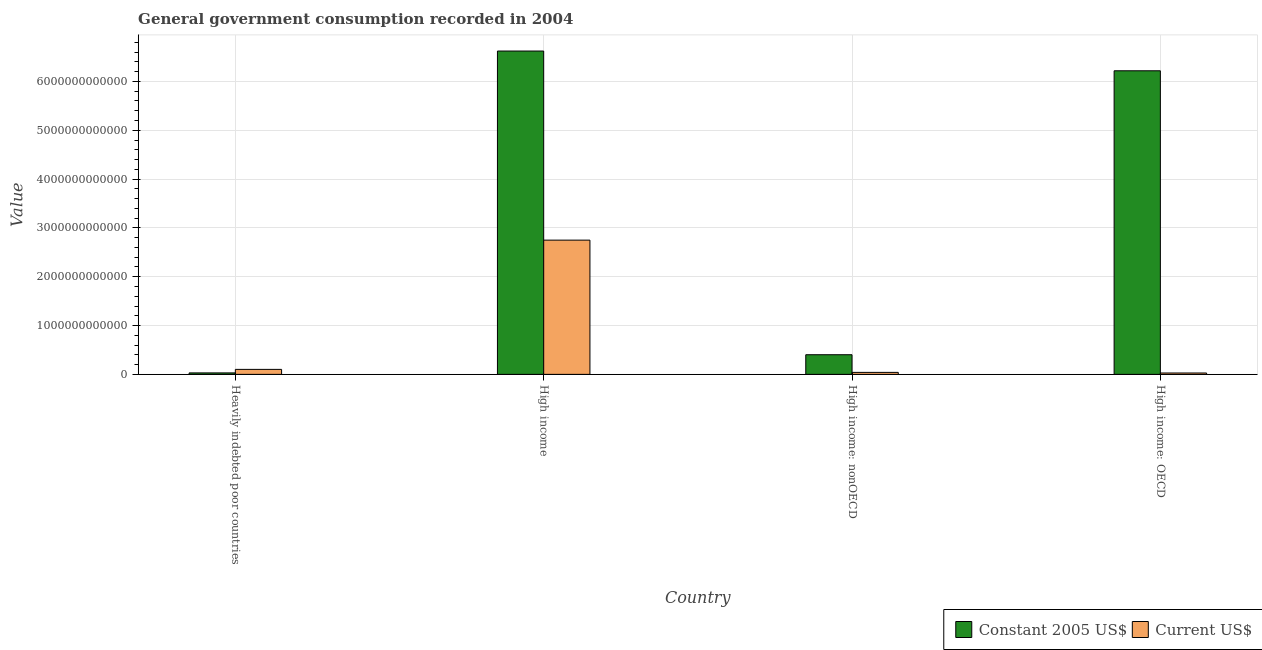How many different coloured bars are there?
Provide a succinct answer. 2. How many groups of bars are there?
Your answer should be very brief. 4. Are the number of bars on each tick of the X-axis equal?
Keep it short and to the point. Yes. What is the label of the 1st group of bars from the left?
Your answer should be very brief. Heavily indebted poor countries. In how many cases, is the number of bars for a given country not equal to the number of legend labels?
Your response must be concise. 0. What is the value consumed in constant 2005 us$ in High income?
Your answer should be compact. 6.62e+12. Across all countries, what is the maximum value consumed in constant 2005 us$?
Provide a short and direct response. 6.62e+12. Across all countries, what is the minimum value consumed in current us$?
Provide a succinct answer. 2.84e+1. In which country was the value consumed in constant 2005 us$ maximum?
Your response must be concise. High income. In which country was the value consumed in constant 2005 us$ minimum?
Provide a short and direct response. Heavily indebted poor countries. What is the total value consumed in constant 2005 us$ in the graph?
Offer a very short reply. 1.33e+13. What is the difference between the value consumed in constant 2005 us$ in Heavily indebted poor countries and that in High income: nonOECD?
Your answer should be very brief. -3.72e+11. What is the difference between the value consumed in current us$ in High income: OECD and the value consumed in constant 2005 us$ in High income?
Ensure brevity in your answer.  -6.59e+12. What is the average value consumed in current us$ per country?
Your answer should be compact. 7.30e+11. What is the difference between the value consumed in constant 2005 us$ and value consumed in current us$ in Heavily indebted poor countries?
Make the answer very short. -7.21e+1. In how many countries, is the value consumed in current us$ greater than 6600000000000 ?
Offer a terse response. 0. What is the ratio of the value consumed in constant 2005 us$ in High income to that in High income: OECD?
Make the answer very short. 1.07. Is the difference between the value consumed in current us$ in High income and High income: OECD greater than the difference between the value consumed in constant 2005 us$ in High income and High income: OECD?
Give a very brief answer. Yes. What is the difference between the highest and the second highest value consumed in constant 2005 us$?
Provide a short and direct response. 4.05e+11. What is the difference between the highest and the lowest value consumed in current us$?
Make the answer very short. 2.72e+12. Is the sum of the value consumed in current us$ in High income and High income: nonOECD greater than the maximum value consumed in constant 2005 us$ across all countries?
Make the answer very short. No. What does the 1st bar from the left in Heavily indebted poor countries represents?
Make the answer very short. Constant 2005 US$. What does the 1st bar from the right in Heavily indebted poor countries represents?
Your response must be concise. Current US$. How many bars are there?
Make the answer very short. 8. How many countries are there in the graph?
Offer a very short reply. 4. What is the difference between two consecutive major ticks on the Y-axis?
Your answer should be compact. 1.00e+12. Does the graph contain any zero values?
Provide a succinct answer. No. Where does the legend appear in the graph?
Offer a terse response. Bottom right. How are the legend labels stacked?
Your answer should be compact. Horizontal. What is the title of the graph?
Ensure brevity in your answer.  General government consumption recorded in 2004. What is the label or title of the Y-axis?
Offer a very short reply. Value. What is the Value of Constant 2005 US$ in Heavily indebted poor countries?
Your answer should be compact. 3.01e+1. What is the Value in Current US$ in Heavily indebted poor countries?
Your answer should be very brief. 1.02e+11. What is the Value in Constant 2005 US$ in High income?
Ensure brevity in your answer.  6.62e+12. What is the Value in Current US$ in High income?
Keep it short and to the point. 2.75e+12. What is the Value of Constant 2005 US$ in High income: nonOECD?
Give a very brief answer. 4.02e+11. What is the Value in Current US$ in High income: nonOECD?
Offer a very short reply. 4.08e+1. What is the Value of Constant 2005 US$ in High income: OECD?
Make the answer very short. 6.22e+12. What is the Value of Current US$ in High income: OECD?
Offer a very short reply. 2.84e+1. Across all countries, what is the maximum Value of Constant 2005 US$?
Keep it short and to the point. 6.62e+12. Across all countries, what is the maximum Value in Current US$?
Provide a short and direct response. 2.75e+12. Across all countries, what is the minimum Value in Constant 2005 US$?
Make the answer very short. 3.01e+1. Across all countries, what is the minimum Value of Current US$?
Keep it short and to the point. 2.84e+1. What is the total Value of Constant 2005 US$ in the graph?
Keep it short and to the point. 1.33e+13. What is the total Value of Current US$ in the graph?
Keep it short and to the point. 2.92e+12. What is the difference between the Value of Constant 2005 US$ in Heavily indebted poor countries and that in High income?
Offer a very short reply. -6.59e+12. What is the difference between the Value in Current US$ in Heavily indebted poor countries and that in High income?
Your response must be concise. -2.65e+12. What is the difference between the Value in Constant 2005 US$ in Heavily indebted poor countries and that in High income: nonOECD?
Keep it short and to the point. -3.72e+11. What is the difference between the Value of Current US$ in Heavily indebted poor countries and that in High income: nonOECD?
Your answer should be very brief. 6.14e+1. What is the difference between the Value of Constant 2005 US$ in Heavily indebted poor countries and that in High income: OECD?
Ensure brevity in your answer.  -6.19e+12. What is the difference between the Value of Current US$ in Heavily indebted poor countries and that in High income: OECD?
Provide a succinct answer. 7.38e+1. What is the difference between the Value in Constant 2005 US$ in High income and that in High income: nonOECD?
Offer a terse response. 6.22e+12. What is the difference between the Value of Current US$ in High income and that in High income: nonOECD?
Your answer should be very brief. 2.71e+12. What is the difference between the Value in Constant 2005 US$ in High income and that in High income: OECD?
Offer a very short reply. 4.05e+11. What is the difference between the Value of Current US$ in High income and that in High income: OECD?
Your answer should be compact. 2.72e+12. What is the difference between the Value in Constant 2005 US$ in High income: nonOECD and that in High income: OECD?
Ensure brevity in your answer.  -5.82e+12. What is the difference between the Value of Current US$ in High income: nonOECD and that in High income: OECD?
Provide a succinct answer. 1.23e+1. What is the difference between the Value of Constant 2005 US$ in Heavily indebted poor countries and the Value of Current US$ in High income?
Provide a succinct answer. -2.72e+12. What is the difference between the Value of Constant 2005 US$ in Heavily indebted poor countries and the Value of Current US$ in High income: nonOECD?
Offer a very short reply. -1.06e+1. What is the difference between the Value in Constant 2005 US$ in Heavily indebted poor countries and the Value in Current US$ in High income: OECD?
Keep it short and to the point. 1.72e+09. What is the difference between the Value of Constant 2005 US$ in High income and the Value of Current US$ in High income: nonOECD?
Offer a terse response. 6.58e+12. What is the difference between the Value of Constant 2005 US$ in High income and the Value of Current US$ in High income: OECD?
Offer a very short reply. 6.59e+12. What is the difference between the Value in Constant 2005 US$ in High income: nonOECD and the Value in Current US$ in High income: OECD?
Keep it short and to the point. 3.74e+11. What is the average Value in Constant 2005 US$ per country?
Ensure brevity in your answer.  3.32e+12. What is the average Value in Current US$ per country?
Keep it short and to the point. 7.30e+11. What is the difference between the Value in Constant 2005 US$ and Value in Current US$ in Heavily indebted poor countries?
Ensure brevity in your answer.  -7.21e+1. What is the difference between the Value in Constant 2005 US$ and Value in Current US$ in High income?
Offer a terse response. 3.87e+12. What is the difference between the Value of Constant 2005 US$ and Value of Current US$ in High income: nonOECD?
Provide a short and direct response. 3.62e+11. What is the difference between the Value of Constant 2005 US$ and Value of Current US$ in High income: OECD?
Offer a very short reply. 6.19e+12. What is the ratio of the Value in Constant 2005 US$ in Heavily indebted poor countries to that in High income?
Offer a terse response. 0. What is the ratio of the Value in Current US$ in Heavily indebted poor countries to that in High income?
Your response must be concise. 0.04. What is the ratio of the Value in Constant 2005 US$ in Heavily indebted poor countries to that in High income: nonOECD?
Provide a succinct answer. 0.07. What is the ratio of the Value in Current US$ in Heavily indebted poor countries to that in High income: nonOECD?
Your answer should be very brief. 2.51. What is the ratio of the Value of Constant 2005 US$ in Heavily indebted poor countries to that in High income: OECD?
Your answer should be compact. 0. What is the ratio of the Value in Current US$ in Heavily indebted poor countries to that in High income: OECD?
Your response must be concise. 3.6. What is the ratio of the Value in Constant 2005 US$ in High income to that in High income: nonOECD?
Offer a terse response. 16.46. What is the ratio of the Value of Current US$ in High income to that in High income: nonOECD?
Give a very brief answer. 67.47. What is the ratio of the Value of Constant 2005 US$ in High income to that in High income: OECD?
Your answer should be compact. 1.07. What is the ratio of the Value of Current US$ in High income to that in High income: OECD?
Provide a succinct answer. 96.8. What is the ratio of the Value in Constant 2005 US$ in High income: nonOECD to that in High income: OECD?
Your answer should be very brief. 0.06. What is the ratio of the Value of Current US$ in High income: nonOECD to that in High income: OECD?
Offer a terse response. 1.43. What is the difference between the highest and the second highest Value in Constant 2005 US$?
Your response must be concise. 4.05e+11. What is the difference between the highest and the second highest Value of Current US$?
Your answer should be compact. 2.65e+12. What is the difference between the highest and the lowest Value of Constant 2005 US$?
Offer a terse response. 6.59e+12. What is the difference between the highest and the lowest Value of Current US$?
Offer a terse response. 2.72e+12. 